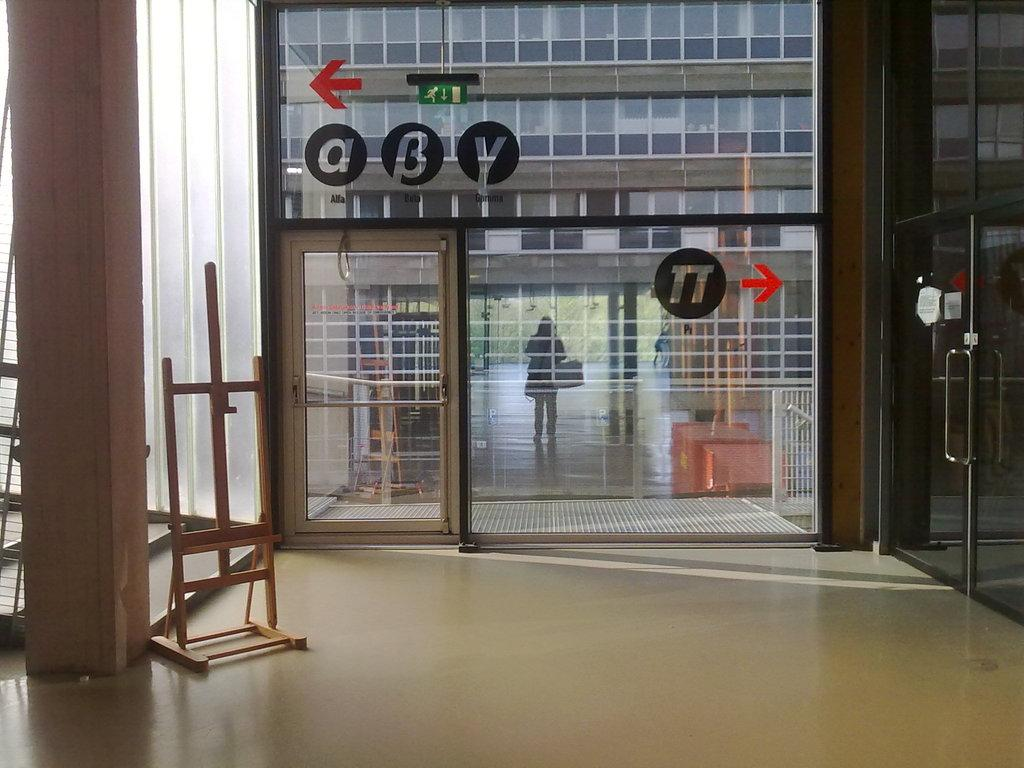What type of surface is visible in the image? There is a floor in the image. What can be seen in the background of the image? There is a glass wall in the background of the image. What is written or displayed on the glass wall? There is text on the glass wall. What type of furniture or structure is present in the image? There is a wooden stand in the image. What architectural feature can be seen in the image? There is a pillar in the image. How many hands are visible holding a sack in the image? There are no hands or sacks visible in the image. What type of sea creature is present in the image? There are no sea creatures, such as clams, present in the image. 